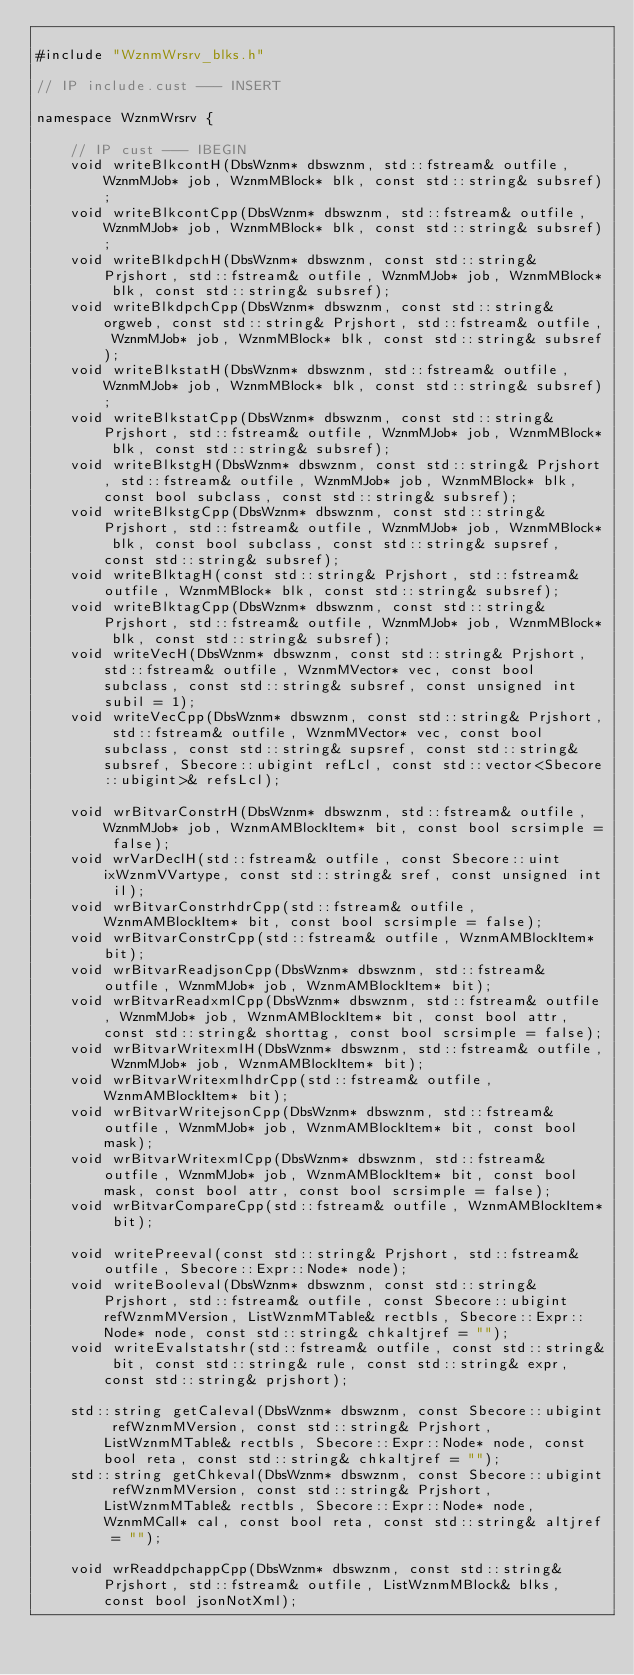<code> <loc_0><loc_0><loc_500><loc_500><_C_>
#include "WznmWrsrv_blks.h"

// IP include.cust --- INSERT

namespace WznmWrsrv {

	// IP cust --- IBEGIN
	void writeBlkcontH(DbsWznm* dbswznm, std::fstream& outfile, WznmMJob* job, WznmMBlock* blk, const std::string& subsref);
	void writeBlkcontCpp(DbsWznm* dbswznm, std::fstream& outfile, WznmMJob* job, WznmMBlock* blk, const std::string& subsref);
	void writeBlkdpchH(DbsWznm* dbswznm, const std::string& Prjshort, std::fstream& outfile, WznmMJob* job, WznmMBlock* blk, const std::string& subsref);
	void writeBlkdpchCpp(DbsWznm* dbswznm, const std::string& orgweb, const std::string& Prjshort, std::fstream& outfile, WznmMJob* job, WznmMBlock* blk, const std::string& subsref);
	void writeBlkstatH(DbsWznm* dbswznm, std::fstream& outfile, WznmMJob* job, WznmMBlock* blk, const std::string& subsref);
	void writeBlkstatCpp(DbsWznm* dbswznm, const std::string& Prjshort, std::fstream& outfile, WznmMJob* job, WznmMBlock* blk, const std::string& subsref);
	void writeBlkstgH(DbsWznm* dbswznm, const std::string& Prjshort, std::fstream& outfile, WznmMJob* job, WznmMBlock* blk, const bool subclass, const std::string& subsref);
	void writeBlkstgCpp(DbsWznm* dbswznm, const std::string& Prjshort, std::fstream& outfile, WznmMJob* job, WznmMBlock* blk, const bool subclass, const std::string& supsref, const std::string& subsref);
	void writeBlktagH(const std::string& Prjshort, std::fstream& outfile, WznmMBlock* blk, const std::string& subsref);
	void writeBlktagCpp(DbsWznm* dbswznm, const std::string& Prjshort, std::fstream& outfile, WznmMJob* job, WznmMBlock* blk, const std::string& subsref);
	void writeVecH(DbsWznm* dbswznm, const std::string& Prjshort, std::fstream& outfile, WznmMVector* vec, const bool subclass, const std::string& subsref, const unsigned int subil = 1);
	void writeVecCpp(DbsWznm* dbswznm, const std::string& Prjshort, std::fstream& outfile, WznmMVector* vec, const bool subclass, const std::string& supsref, const std::string& subsref, Sbecore::ubigint refLcl, const std::vector<Sbecore::ubigint>& refsLcl);

	void wrBitvarConstrH(DbsWznm* dbswznm, std::fstream& outfile, WznmMJob* job, WznmAMBlockItem* bit, const bool scrsimple = false);
	void wrVarDeclH(std::fstream& outfile, const Sbecore::uint ixWznmVVartype, const std::string& sref, const unsigned int il);
	void wrBitvarConstrhdrCpp(std::fstream& outfile, WznmAMBlockItem* bit, const bool scrsimple = false);
	void wrBitvarConstrCpp(std::fstream& outfile, WznmAMBlockItem* bit);
	void wrBitvarReadjsonCpp(DbsWznm* dbswznm, std::fstream& outfile, WznmMJob* job, WznmAMBlockItem* bit);
	void wrBitvarReadxmlCpp(DbsWznm* dbswznm, std::fstream& outfile, WznmMJob* job, WznmAMBlockItem* bit, const bool attr, const std::string& shorttag, const bool scrsimple = false);
	void wrBitvarWritexmlH(DbsWznm* dbswznm, std::fstream& outfile, WznmMJob* job, WznmAMBlockItem* bit);
	void wrBitvarWritexmlhdrCpp(std::fstream& outfile, WznmAMBlockItem* bit);
	void wrBitvarWritejsonCpp(DbsWznm* dbswznm, std::fstream& outfile, WznmMJob* job, WznmAMBlockItem* bit, const bool mask);
	void wrBitvarWritexmlCpp(DbsWznm* dbswznm, std::fstream& outfile, WznmMJob* job, WznmAMBlockItem* bit, const bool mask, const bool attr, const bool scrsimple = false);
	void wrBitvarCompareCpp(std::fstream& outfile, WznmAMBlockItem* bit);

	void writePreeval(const std::string& Prjshort, std::fstream& outfile, Sbecore::Expr::Node* node);
	void writeBooleval(DbsWznm* dbswznm, const std::string& Prjshort, std::fstream& outfile, const Sbecore::ubigint refWznmMVersion, ListWznmMTable& rectbls, Sbecore::Expr::Node* node, const std::string& chkaltjref = "");
	void writeEvalstatshr(std::fstream& outfile, const std::string& bit, const std::string& rule, const std::string& expr, const std::string& prjshort);

	std::string getCaleval(DbsWznm* dbswznm, const Sbecore::ubigint refWznmMVersion, const std::string& Prjshort, ListWznmMTable& rectbls, Sbecore::Expr::Node* node, const bool reta, const std::string& chkaltjref = "");
	std::string getChkeval(DbsWznm* dbswznm, const Sbecore::ubigint refWznmMVersion, const std::string& Prjshort, ListWznmMTable& rectbls, Sbecore::Expr::Node* node, WznmMCall* cal, const bool reta, const std::string& altjref = "");

	void wrReaddpchappCpp(DbsWznm* dbswznm, const std::string& Prjshort, std::fstream& outfile, ListWznmMBlock& blks, const bool jsonNotXml);
</code> 